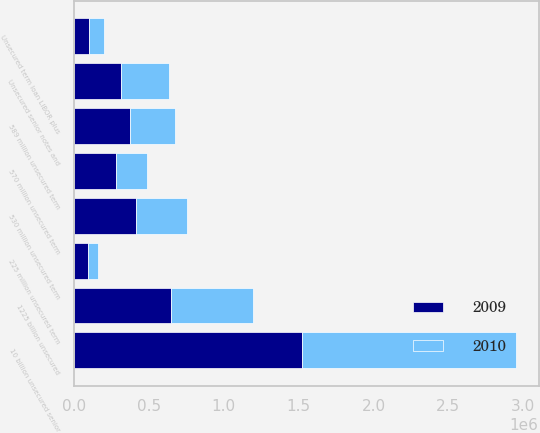<chart> <loc_0><loc_0><loc_500><loc_500><stacked_bar_chart><ecel><fcel>1225 billion unsecured<fcel>Unsecured senior notes and<fcel>10 billion unsecured senior<fcel>Unsecured term loan LIBOR plus<fcel>225 million unsecured term<fcel>570 million unsecured term<fcel>589 million unsecured term<fcel>530 million unsecured term<nl><fcel>2010<fcel>545000<fcel>317607<fcel>1.42732e+06<fcel>100000<fcel>64238<fcel>203571<fcel>294500<fcel>340714<nl><fcel>2009<fcel>650000<fcel>317607<fcel>1.52613e+06<fcel>100000<fcel>96390<fcel>285000<fcel>378643<fcel>416429<nl></chart> 